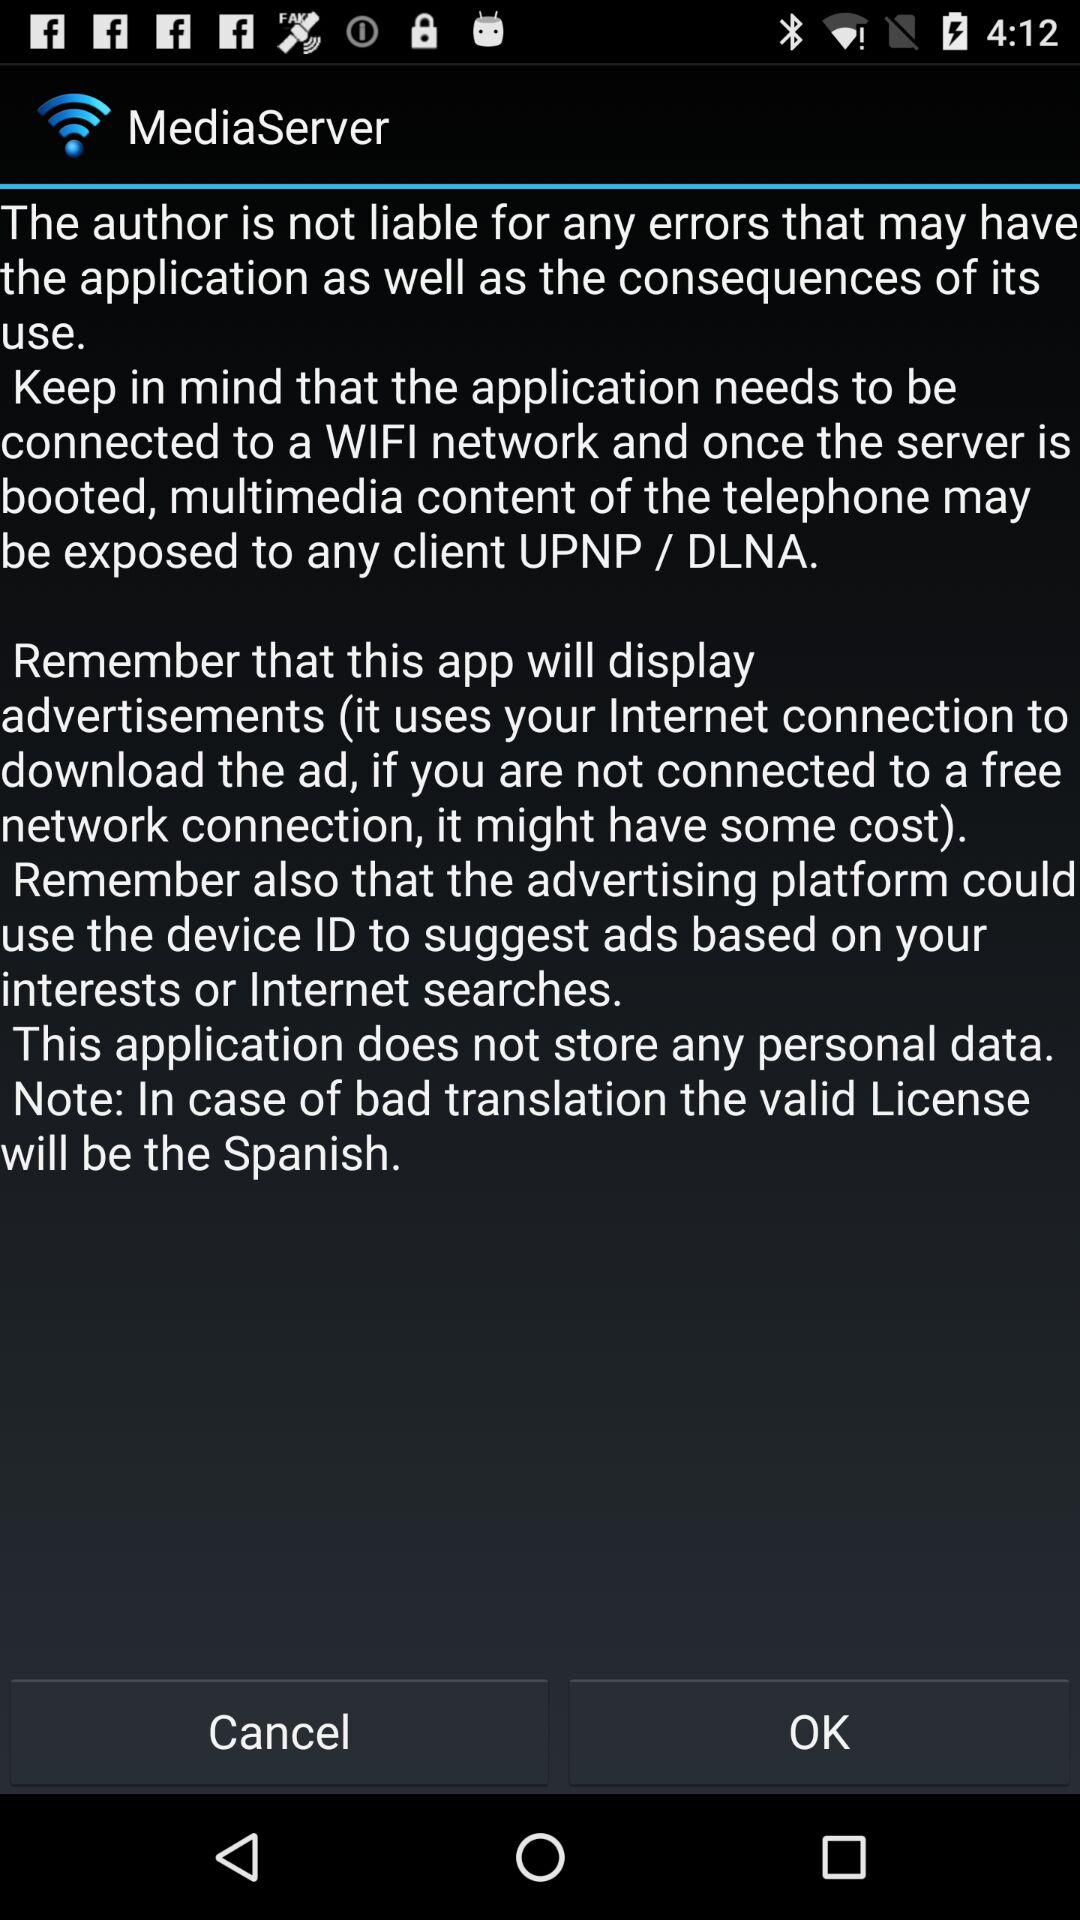What is the app name? The app name is "MediaServer". 